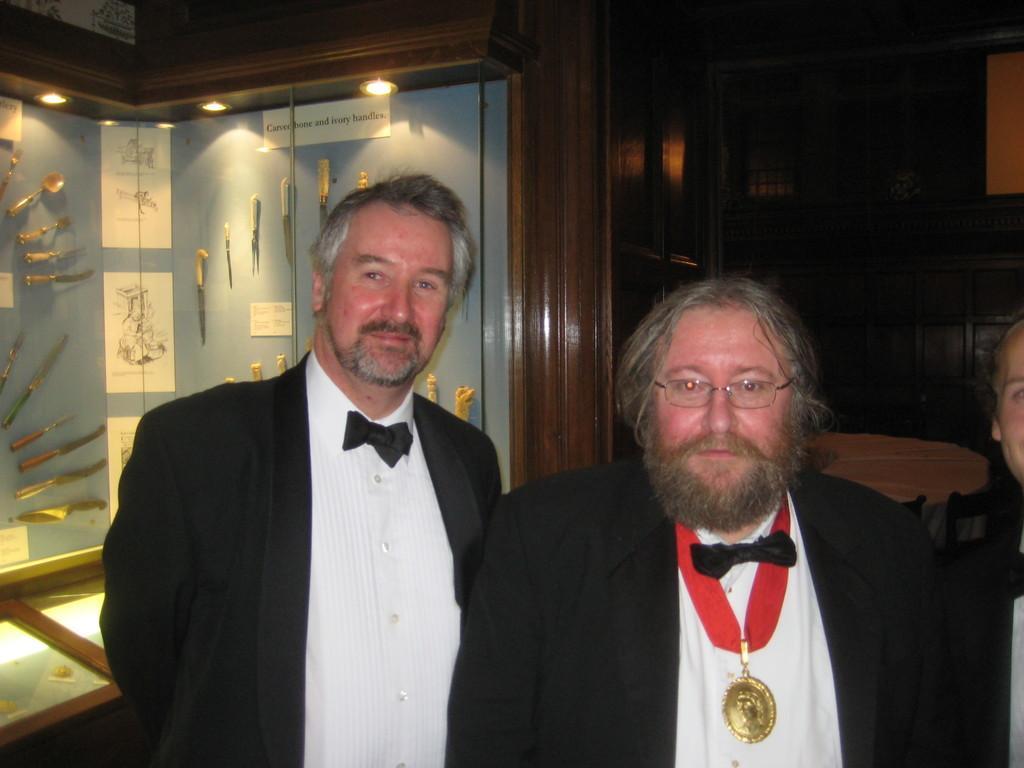Describe this image in one or two sentences. In this image I can see three persons , backside of them I can see rack , in the rack I can see knives attached to the wall and there is a lighting visible at the top. 